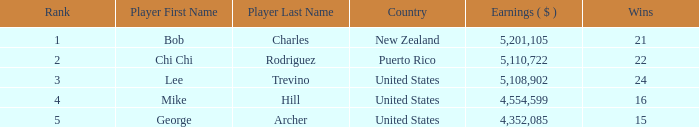What is the lowest level of Earnings($) to have a Wins value of 22 and a Rank lower than 2? None. 